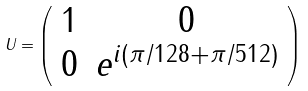<formula> <loc_0><loc_0><loc_500><loc_500>U = \left ( \begin{array} { c c c c } 1 & 0 \\ 0 & e ^ { i ( \pi / 1 2 8 + \pi / 5 1 2 ) } \end{array} \right )</formula> 